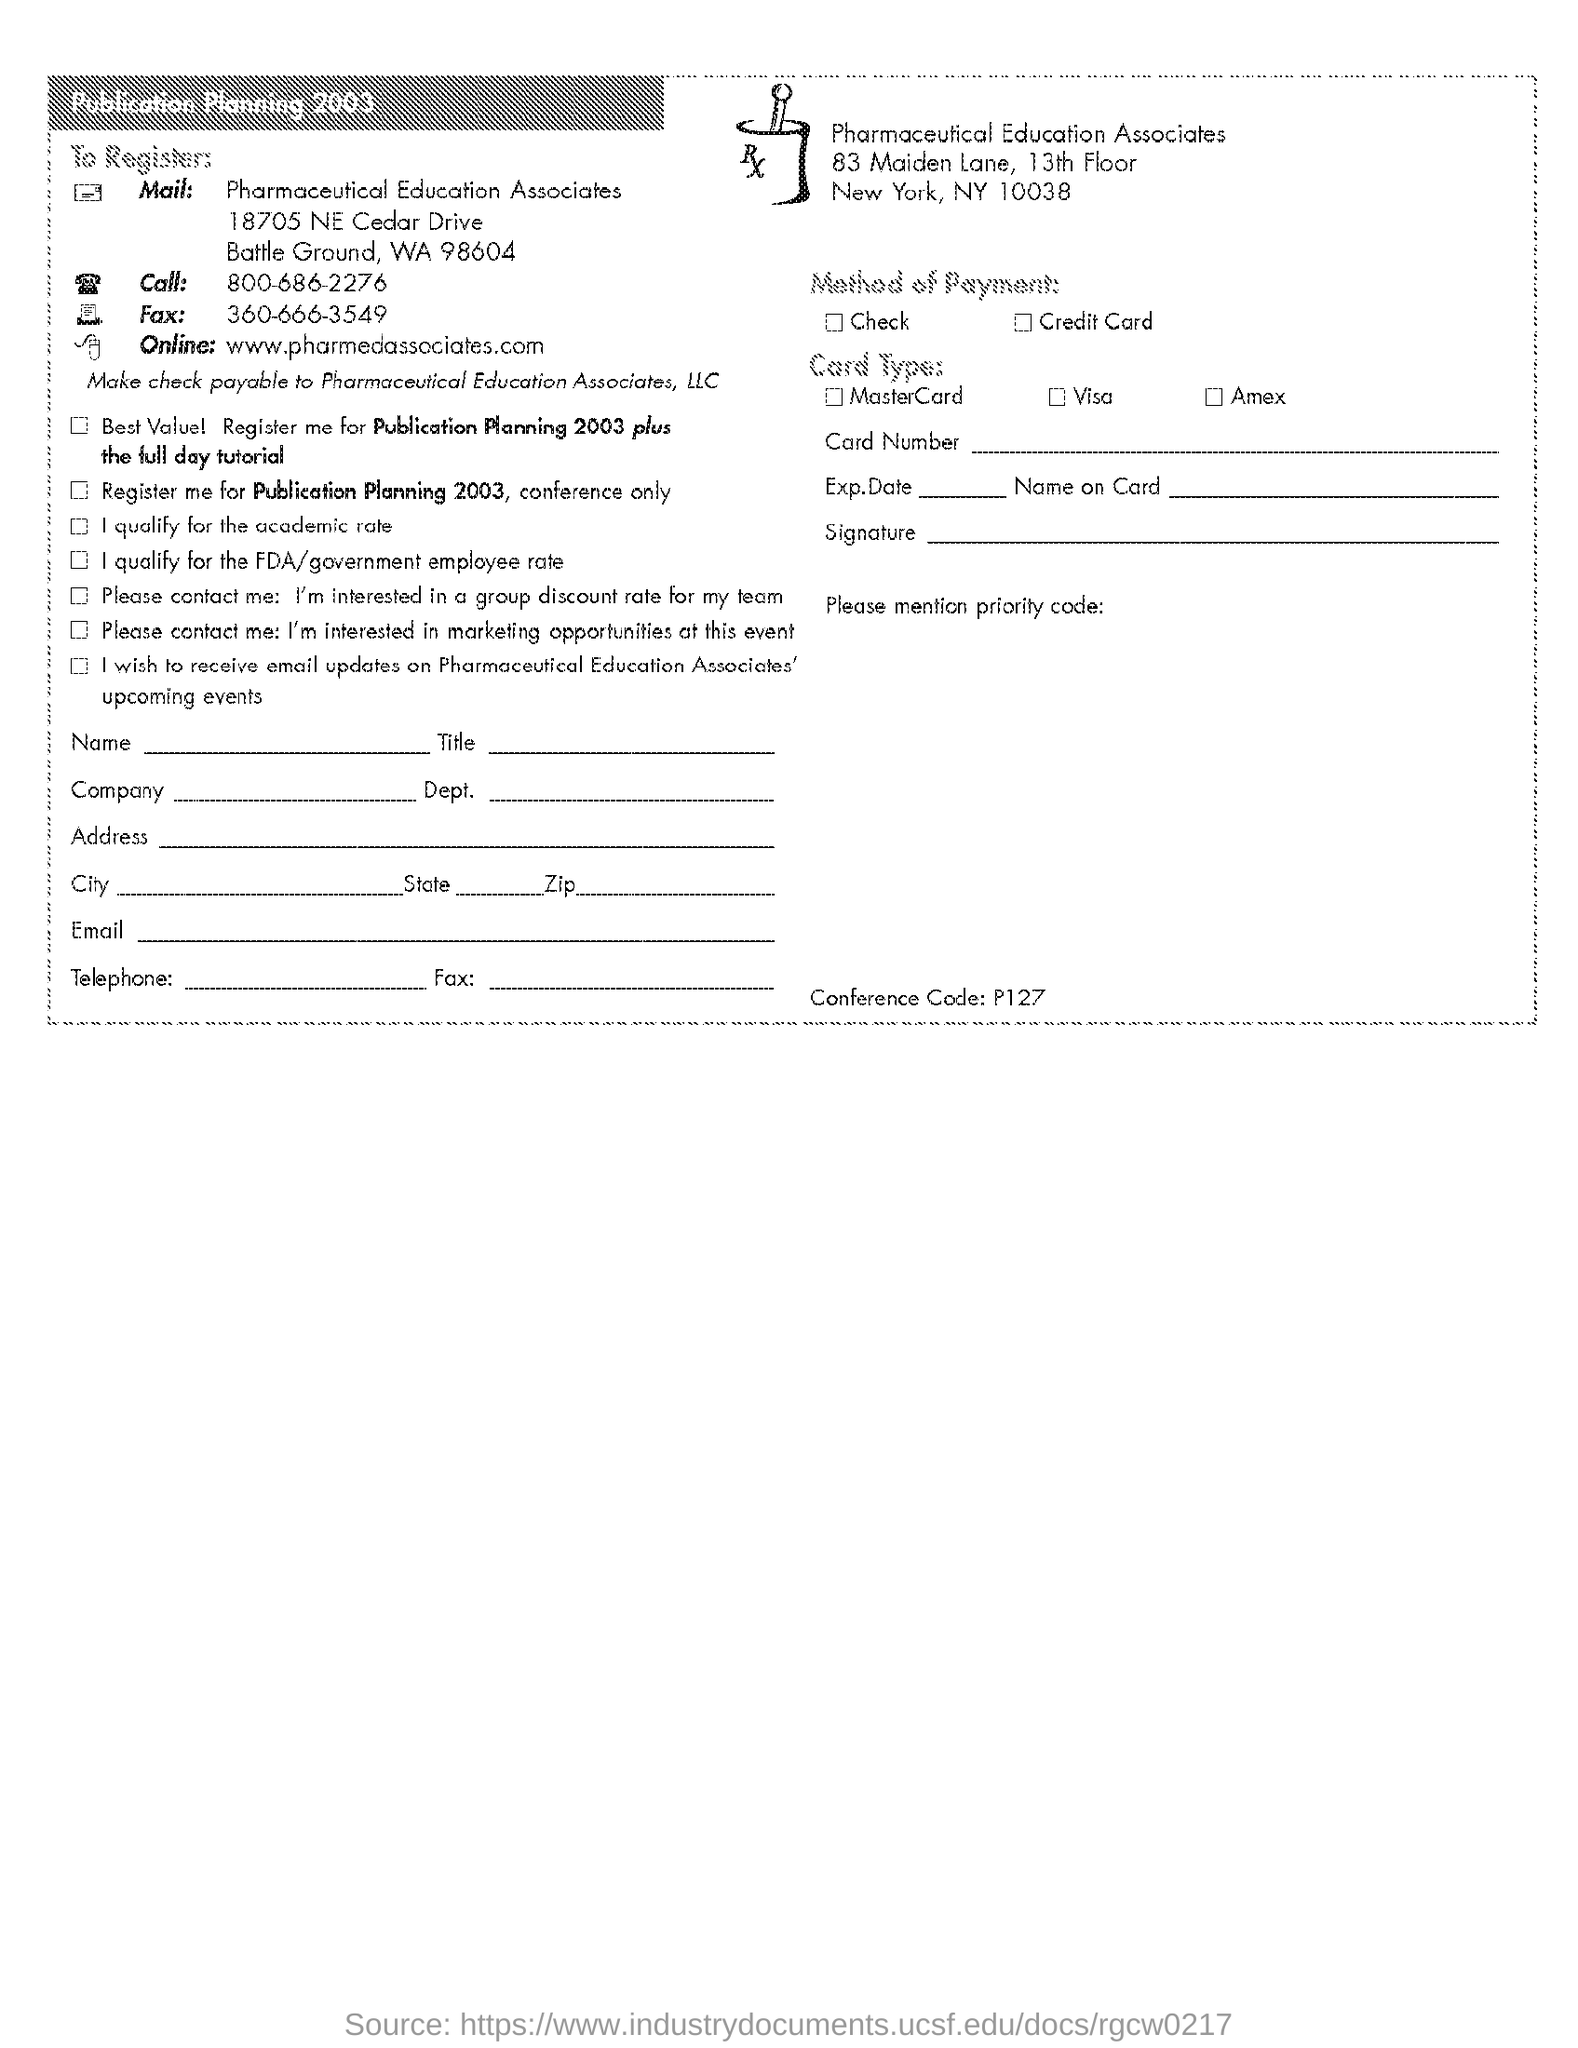Draw attention to some important aspects in this diagram. Pharmaceutical Education Associates is the mentioned firm. The conference code is P127. The website mentioned for registration is pharmedassociates.com. The fax number provided is 360-666-3549. The telephone number given is 800-686-2276. 